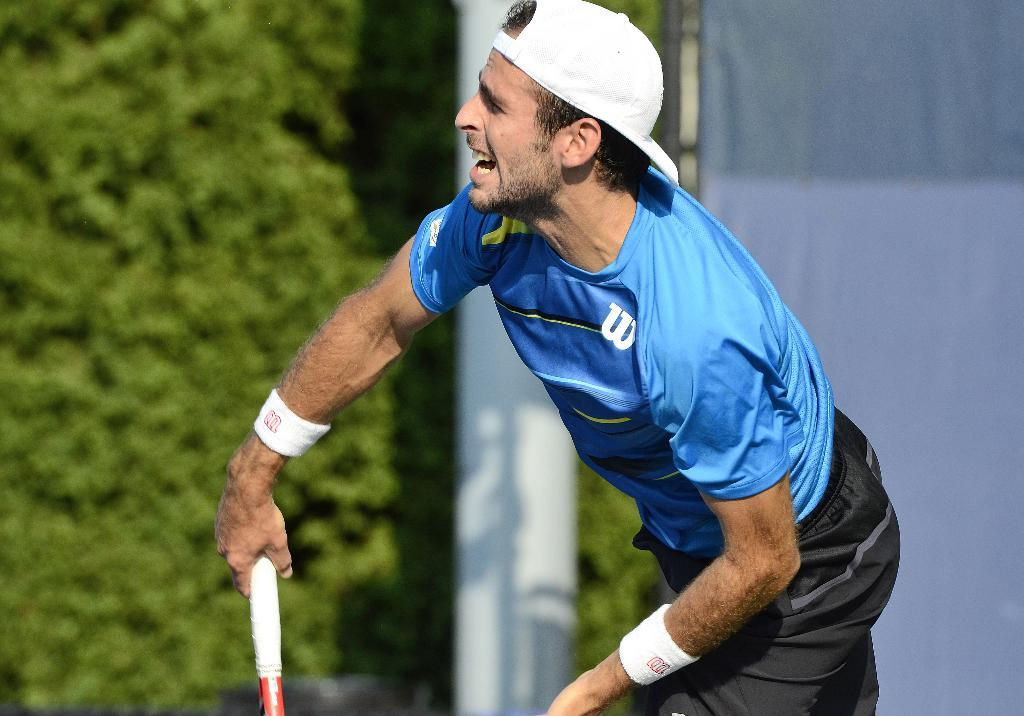Who is present in the image? There is a man in the image. What is the man wearing on his head? The man is wearing a hat. What is the man doing in the image? The man is standing and holding an object. Can you describe the background of the image? The background of the image is blurred. What type of chicken is being used to change the channel on the TV in the image? There is no chicken or TV present in the image, and therefore no such activity can be observed. What type of blade is being used by the man in the image? There is no blade visible in the image; the man is simply holding an object. 